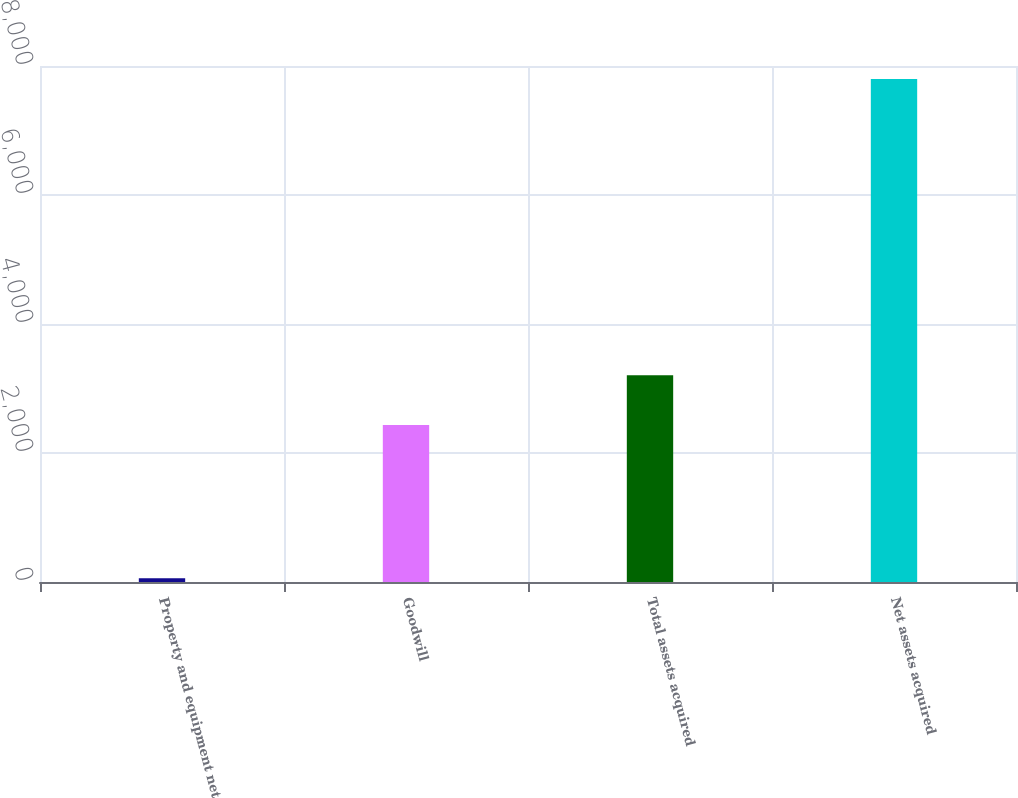Convert chart. <chart><loc_0><loc_0><loc_500><loc_500><bar_chart><fcel>Property and equipment net<fcel>Goodwill<fcel>Total assets acquired<fcel>Net assets acquired<nl><fcel>57<fcel>2433<fcel>3207.3<fcel>7800<nl></chart> 